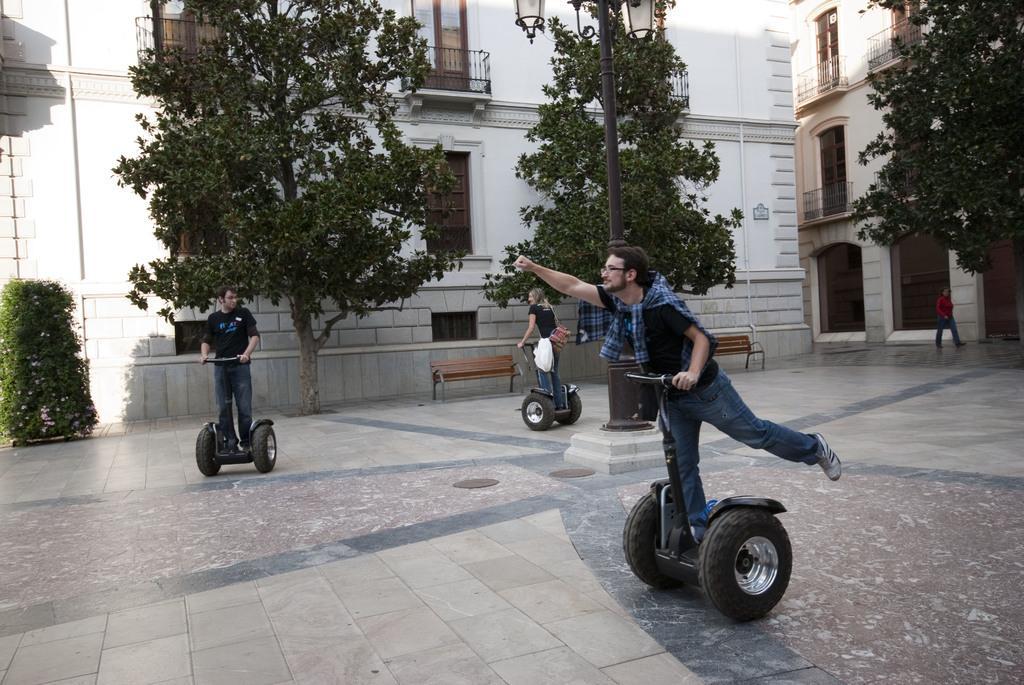How would you summarize this image in a sentence or two? In the image we can see there are people wearing clothes, shoes and they are riding on the mini scooter. Here we can see benches, trees, buildings and windows of the buildings. Here we can see light pole, floor, plant and we can see a person walking. 